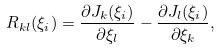<formula> <loc_0><loc_0><loc_500><loc_500>R _ { k l } ( \xi _ { i } ) = \frac { \partial J _ { k } ( \xi _ { i } ) } { \partial \xi _ { l } } - \frac { \partial J _ { l } ( \xi _ { i } ) } { \partial \xi _ { k } } ,</formula> 